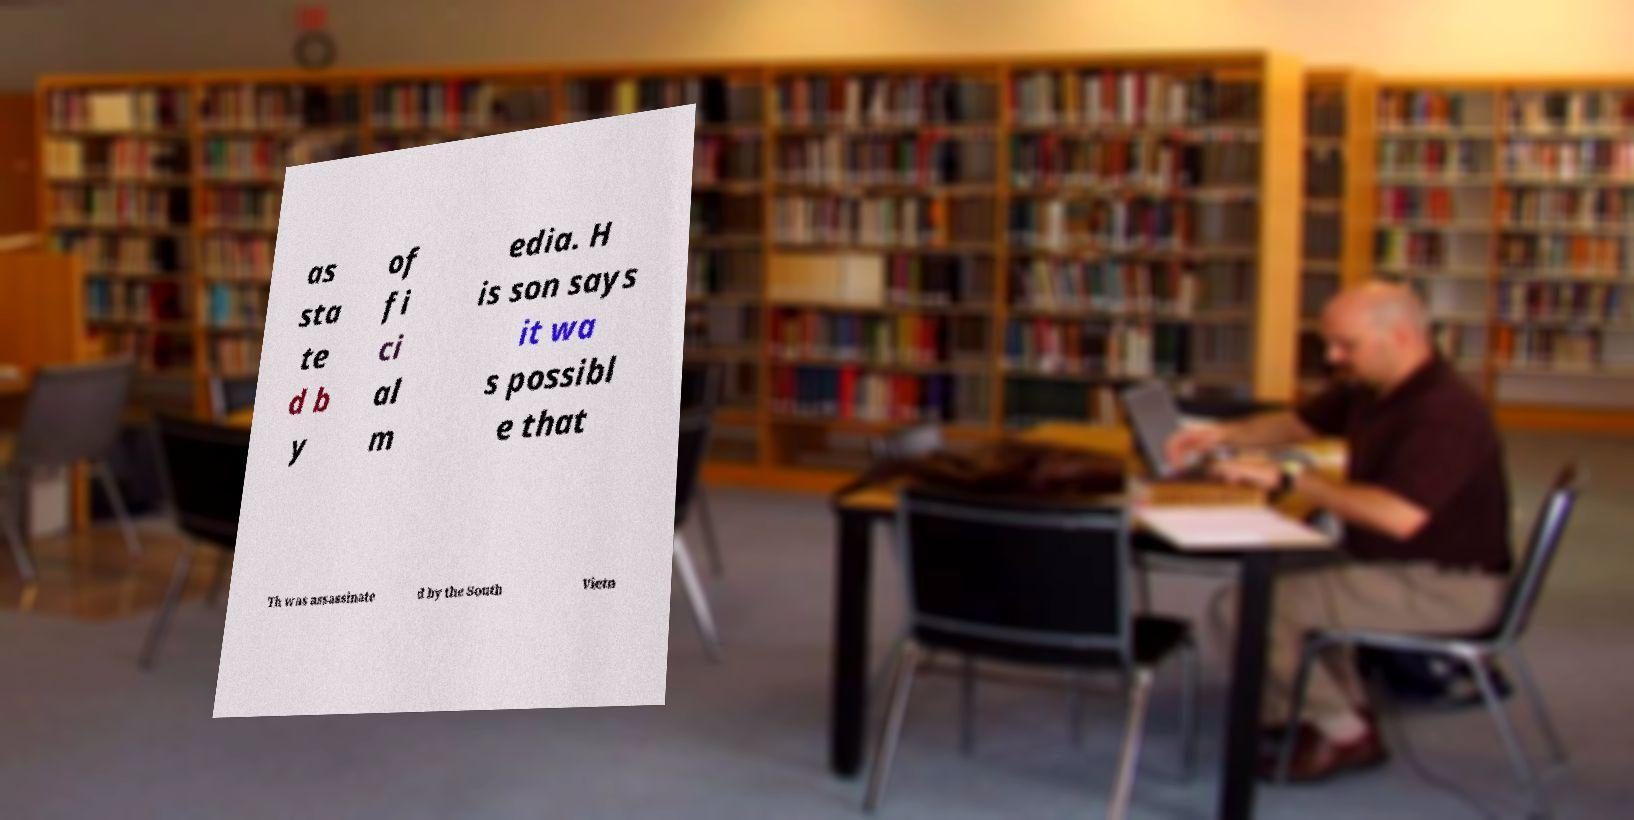Could you assist in decoding the text presented in this image and type it out clearly? as sta te d b y of fi ci al m edia. H is son says it wa s possibl e that Th was assassinate d by the South Vietn 